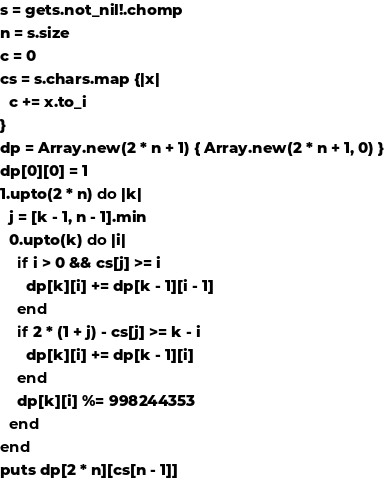Convert code to text. <code><loc_0><loc_0><loc_500><loc_500><_Crystal_>s = gets.not_nil!.chomp
n = s.size
c = 0
cs = s.chars.map {|x|
  c += x.to_i
}
dp = Array.new(2 * n + 1) { Array.new(2 * n + 1, 0) }
dp[0][0] = 1
1.upto(2 * n) do |k|
  j = [k - 1, n - 1].min
  0.upto(k) do |i|
    if i > 0 && cs[j] >= i
      dp[k][i] += dp[k - 1][i - 1]
    end
    if 2 * (1 + j) - cs[j] >= k - i
      dp[k][i] += dp[k - 1][i]
    end
    dp[k][i] %= 998244353
  end
end
puts dp[2 * n][cs[n - 1]]</code> 